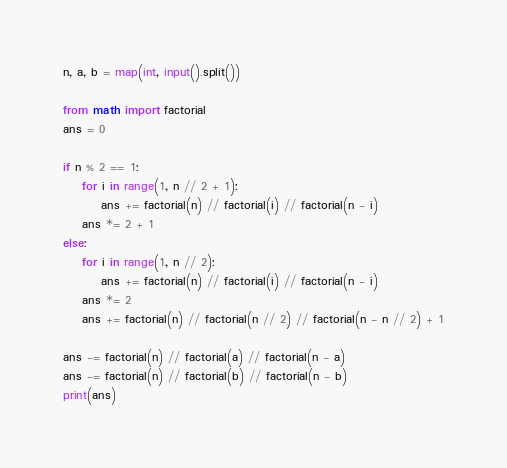<code> <loc_0><loc_0><loc_500><loc_500><_Python_>n, a, b = map(int, input().split())

from math import factorial
ans = 0

if n % 2 == 1:
    for i in range(1, n // 2 + 1):
        ans += factorial(n) // factorial(i) // factorial(n - i)
    ans *= 2 + 1
else:
    for i in range(1, n // 2):
        ans += factorial(n) // factorial(i) // factorial(n - i)
    ans *= 2
    ans += factorial(n) // factorial(n // 2) // factorial(n - n // 2) + 1

ans -= factorial(n) // factorial(a) // factorial(n - a)
ans -= factorial(n) // factorial(b) // factorial(n - b)
print(ans)</code> 